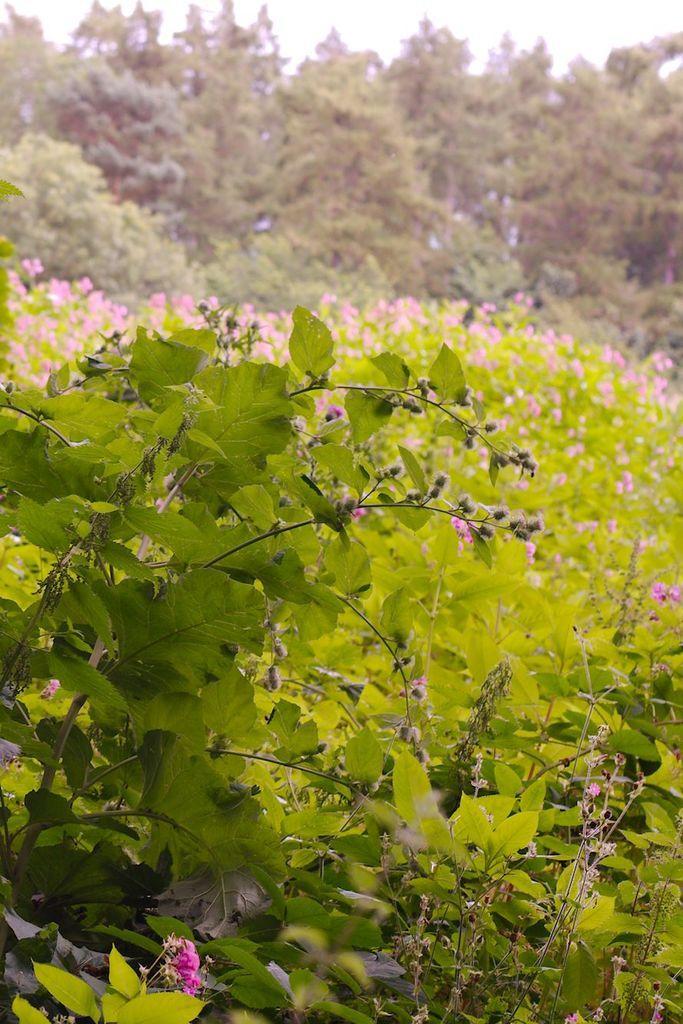How would you summarize this image in a sentence or two? In this image there are plants and trees. 